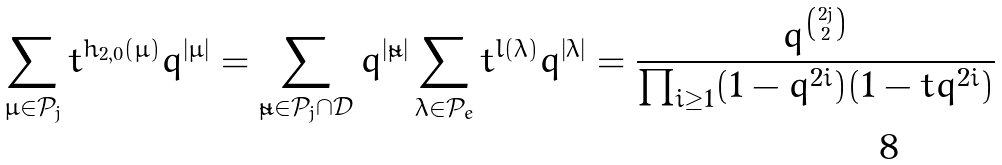Convert formula to latex. <formula><loc_0><loc_0><loc_500><loc_500>\sum _ { \mu \in \mathcal { P } _ { j } } t ^ { h _ { 2 , 0 } ( \mu ) } q ^ { | \mu | } = \sum _ { \tilde { \mu } \in \mathcal { P } _ { j } \cap \mathcal { D } } q ^ { | \tilde { \mu } | } \sum _ { \lambda \in \mathcal { P } _ { e } } t ^ { l ( \lambda ) } q ^ { | \lambda | } = \frac { q ^ { 2 j \choose 2 } } { \prod _ { i \geq 1 } ( 1 - q ^ { 2 i } ) ( 1 - t q ^ { 2 i } ) }</formula> 